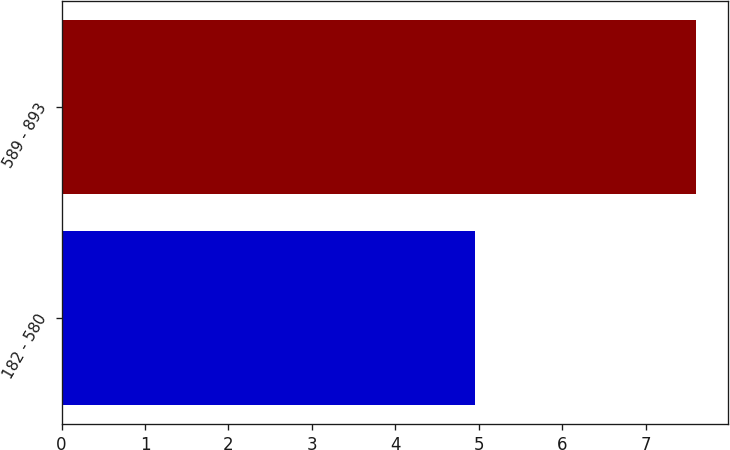Convert chart to OTSL. <chart><loc_0><loc_0><loc_500><loc_500><bar_chart><fcel>182 - 580<fcel>589 - 893<nl><fcel>4.95<fcel>7.61<nl></chart> 